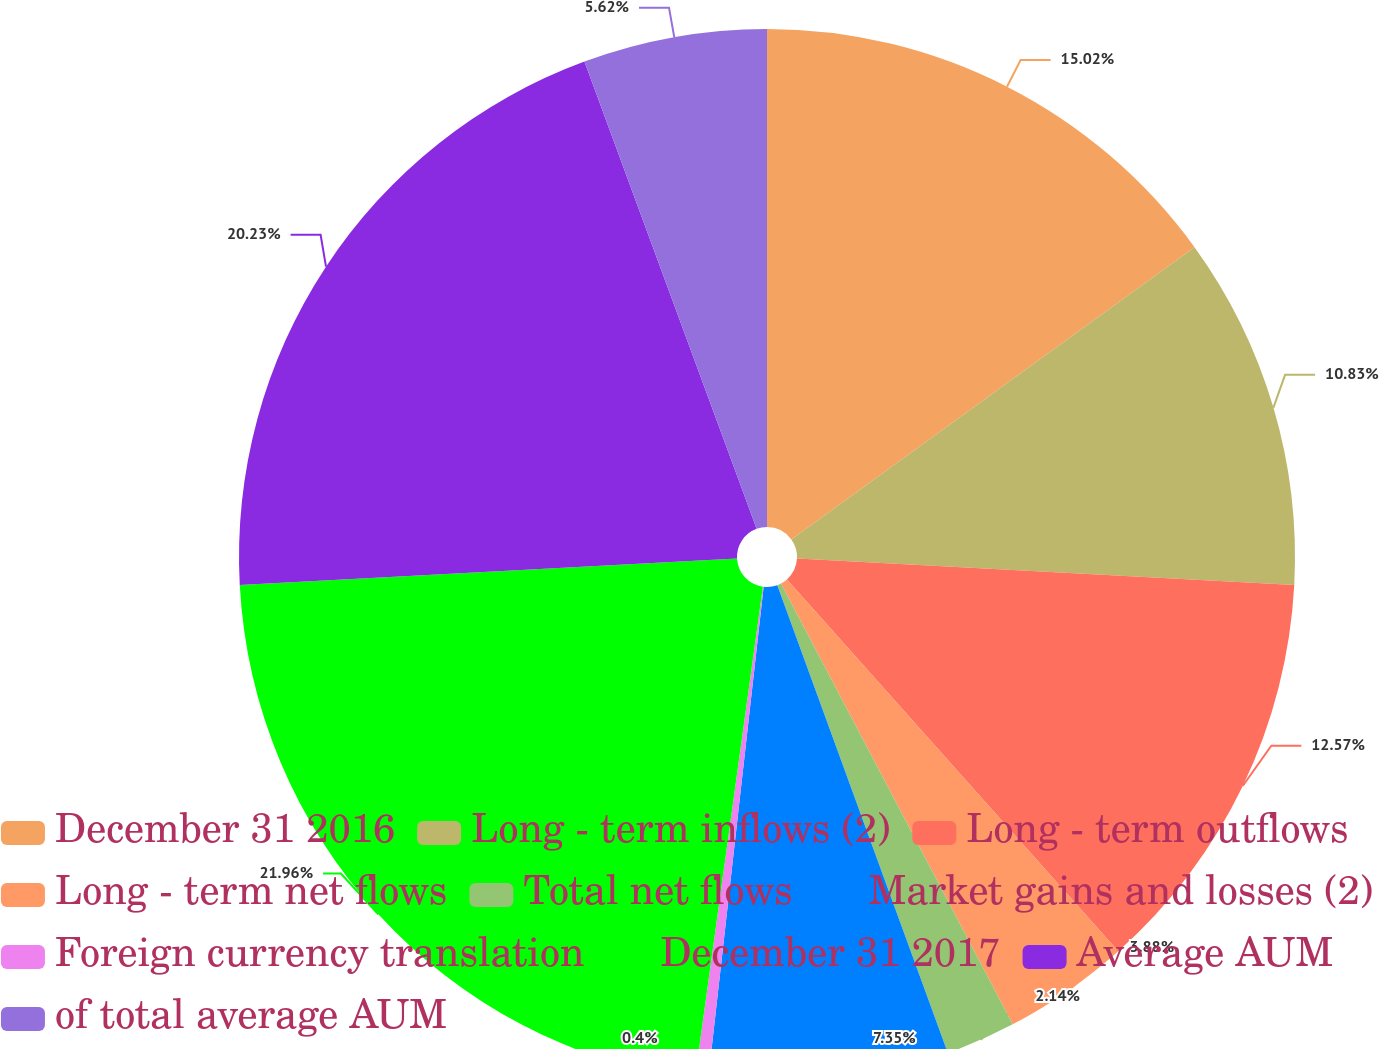<chart> <loc_0><loc_0><loc_500><loc_500><pie_chart><fcel>December 31 2016<fcel>Long - term inflows (2)<fcel>Long - term outflows<fcel>Long - term net flows<fcel>Total net flows<fcel>Market gains and losses (2)<fcel>Foreign currency translation<fcel>December 31 2017<fcel>Average AUM<fcel>of total average AUM<nl><fcel>15.02%<fcel>10.83%<fcel>12.57%<fcel>3.88%<fcel>2.14%<fcel>7.35%<fcel>0.4%<fcel>21.97%<fcel>20.23%<fcel>5.62%<nl></chart> 